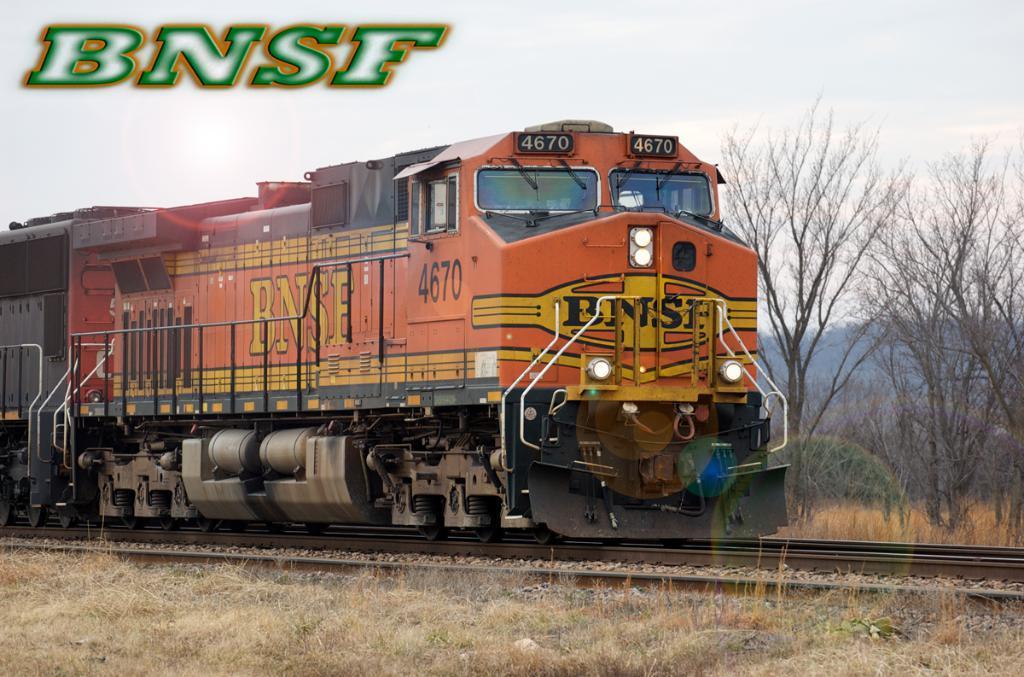Describe this image in one or two sentences. This picture shows a train on the railway track and we see trees and grass on the ground and we see text on the top left corner of the picture and we see a cloudy sky. 